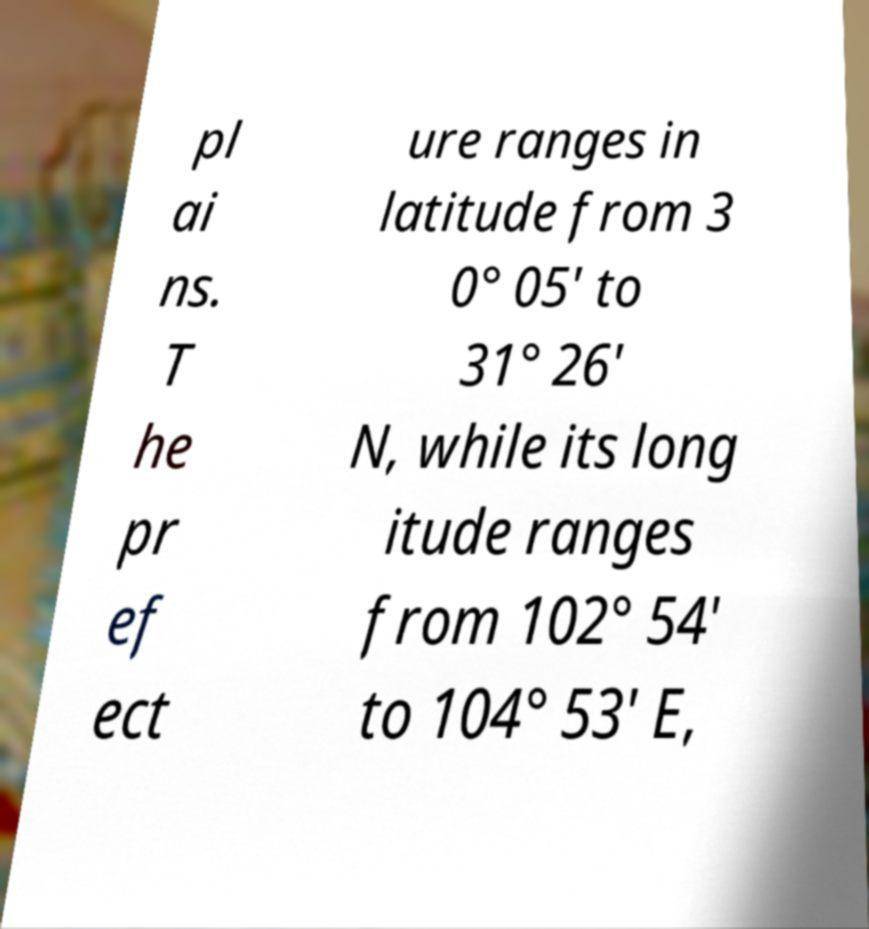Could you assist in decoding the text presented in this image and type it out clearly? pl ai ns. T he pr ef ect ure ranges in latitude from 3 0° 05' to 31° 26' N, while its long itude ranges from 102° 54' to 104° 53' E, 